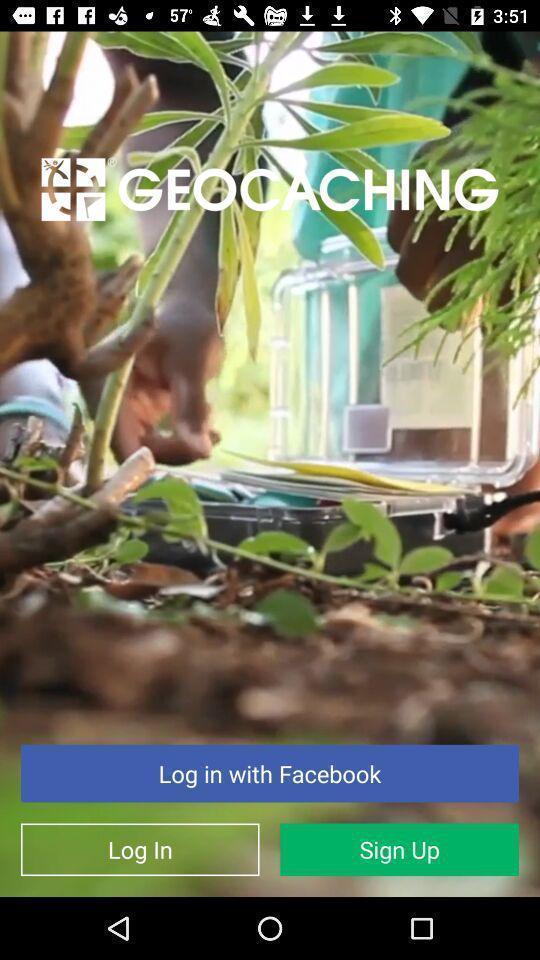Describe the content in this image. Page with multiple login options. 